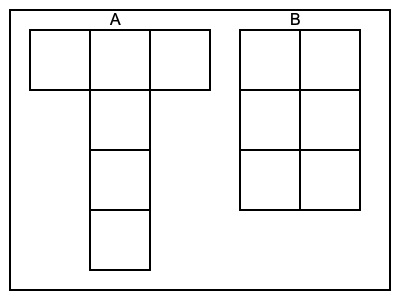As an IT specialist working on a 3D modeling project, you need to choose the correct unfolded net of a cube for a virtual environment. Which of the two nets (A or B) shown in the diagram represents a valid unfolded cube that can be folded into a complete cube without any overlapping faces? To determine which net is the correct unfolded representation of a cube, we need to follow these steps:

1. Count the faces: A cube has 6 faces. Both nets A and B have 6 squares, so they both pass this initial check.

2. Analyze the connectivity:
   - Net A: The squares are connected in a 'T' shape with one long column and one row at the top.
   - Net B: The squares are arranged in a 2x3 rectangular grid.

3. Mentally fold the nets:
   - Net A: 
     * The top row can fold to form three sides of the cube.
     * The column below can fold to form the remaining three sides.
     * All faces connect properly without overlapping.
   
   - Net B:
     * When trying to fold this net, we encounter a problem.
     * The four corner squares can form four sides of the cube.
     * However, the two middle squares on opposite sides cannot both become the remaining two faces of the cube without overlapping.

4. Conclusion:
   Net A can be folded into a cube without any overlapping faces.
   Net B cannot be folded into a cube without face overlaps.

In the context of 3D modeling for a virtual environment, choosing the correct net is crucial for accurate representation and rendering of cubic objects.
Answer: A 